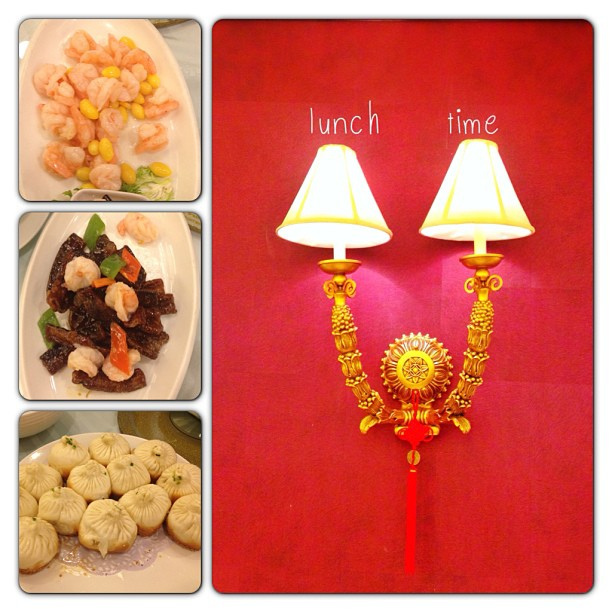Please transcribe the text information in this image. lunch time 